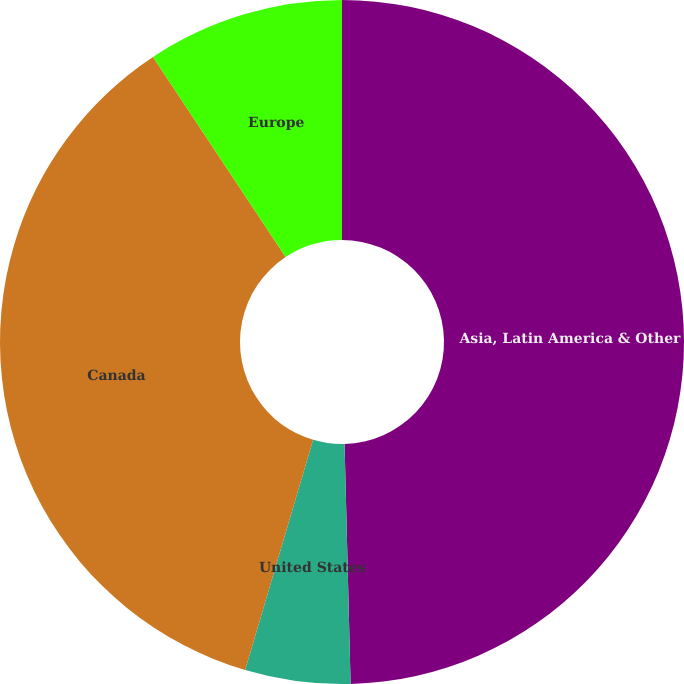<chart> <loc_0><loc_0><loc_500><loc_500><pie_chart><fcel>Asia, Latin America & Other<fcel>United States<fcel>Canada<fcel>Europe<nl><fcel>49.6%<fcel>4.97%<fcel>36.11%<fcel>9.32%<nl></chart> 